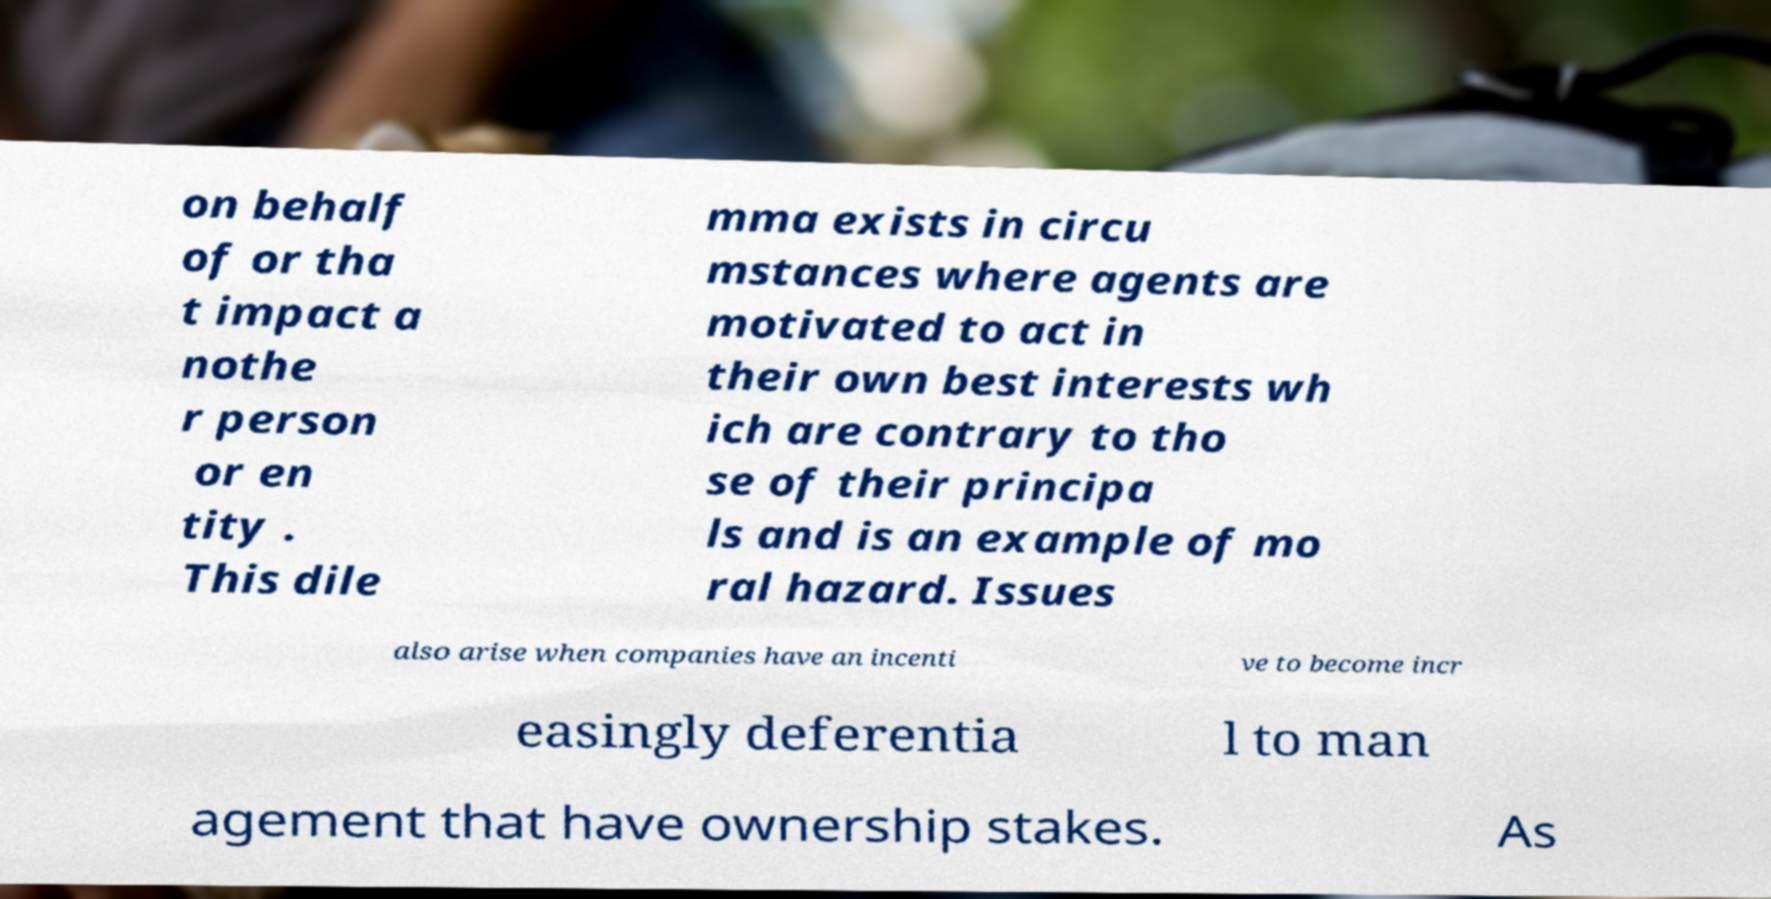Could you extract and type out the text from this image? on behalf of or tha t impact a nothe r person or en tity . This dile mma exists in circu mstances where agents are motivated to act in their own best interests wh ich are contrary to tho se of their principa ls and is an example of mo ral hazard. Issues also arise when companies have an incenti ve to become incr easingly deferentia l to man agement that have ownership stakes. As 